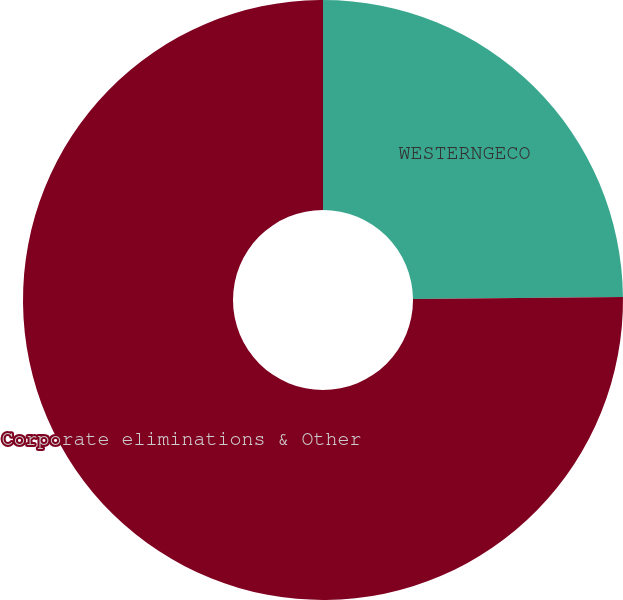Convert chart to OTSL. <chart><loc_0><loc_0><loc_500><loc_500><pie_chart><fcel>WESTERNGECO<fcel>Corporate eliminations & Other<nl><fcel>24.84%<fcel>75.16%<nl></chart> 